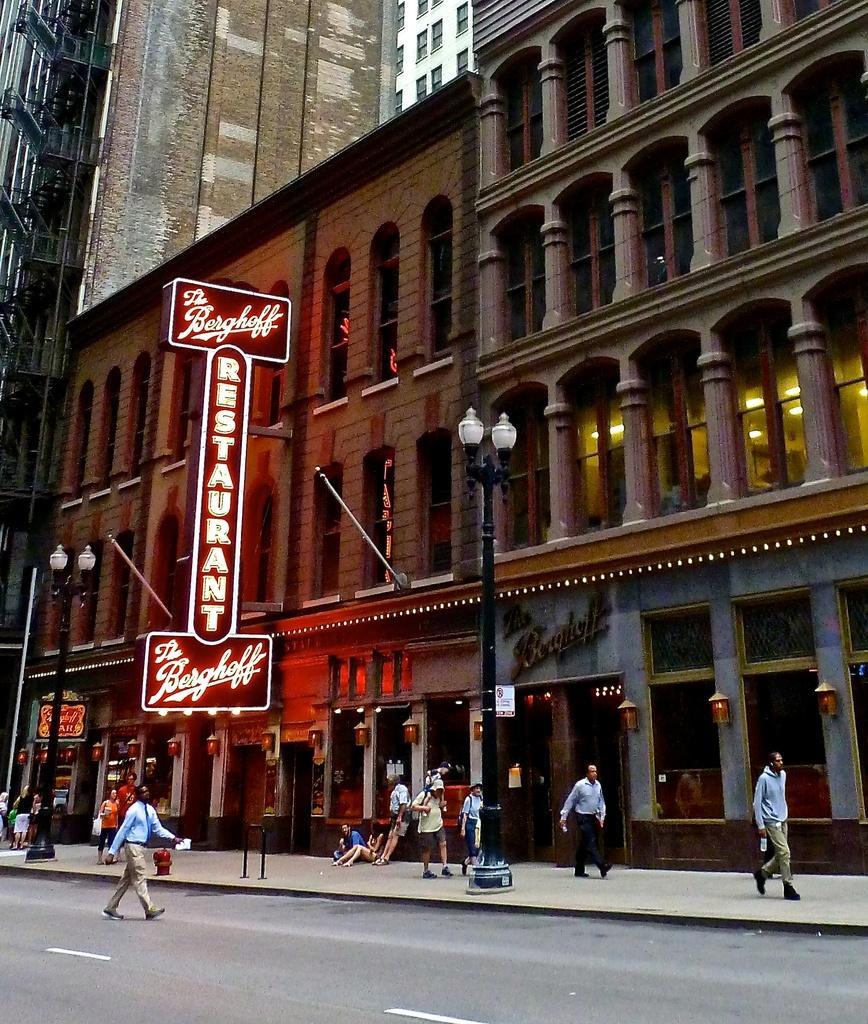Please provide a concise description of this image. This picture is clicked outside on the road. In the center we can see the group of people walking on a sidewalk and there are two persons sitting on the ground and there is a red color board on which the text is printed and we can see the lights are attached to the poles. In the background we can see the buildings. 